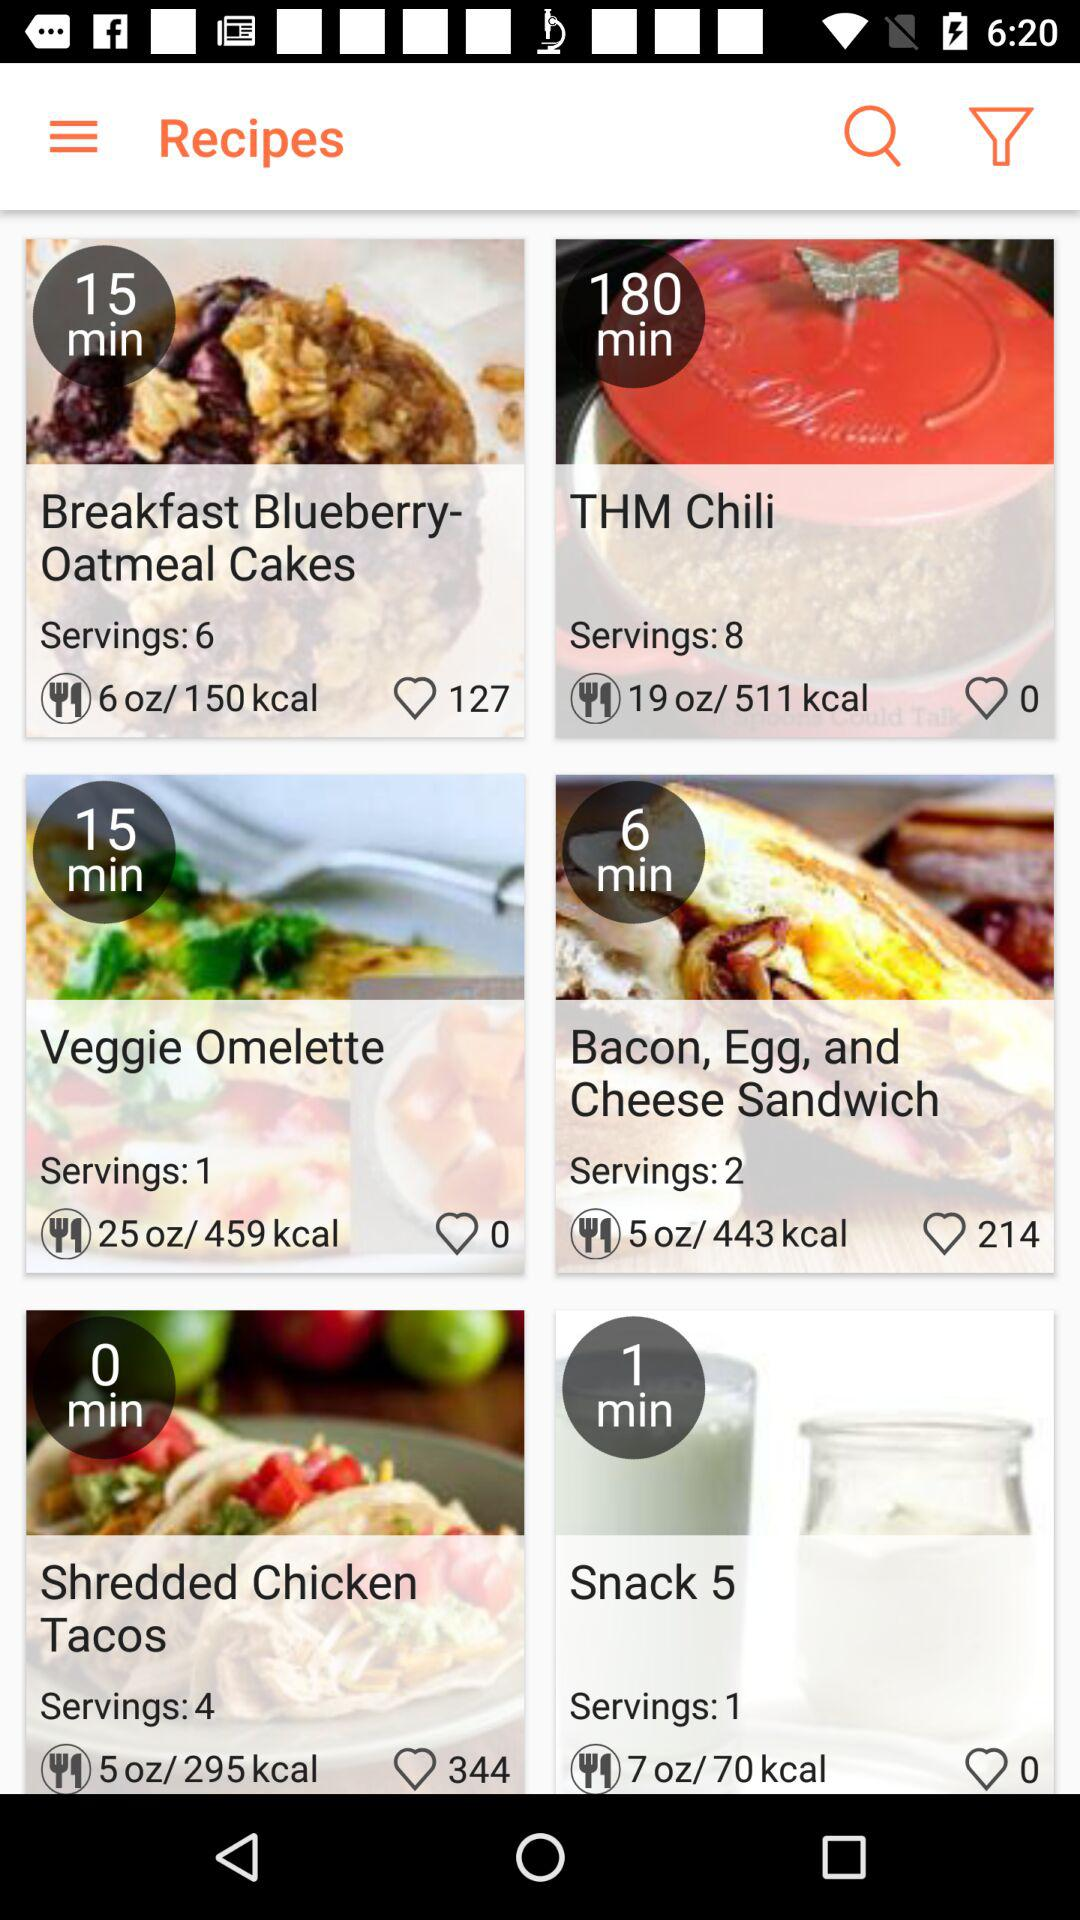How many likes are there for "Bacon, Egg, and Cheese Sandwich"? There are 214 likes. 